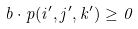Convert formula to latex. <formula><loc_0><loc_0><loc_500><loc_500>b \cdot p ( i ^ { \prime } , j ^ { \prime } , k ^ { \prime } ) \geq 0</formula> 